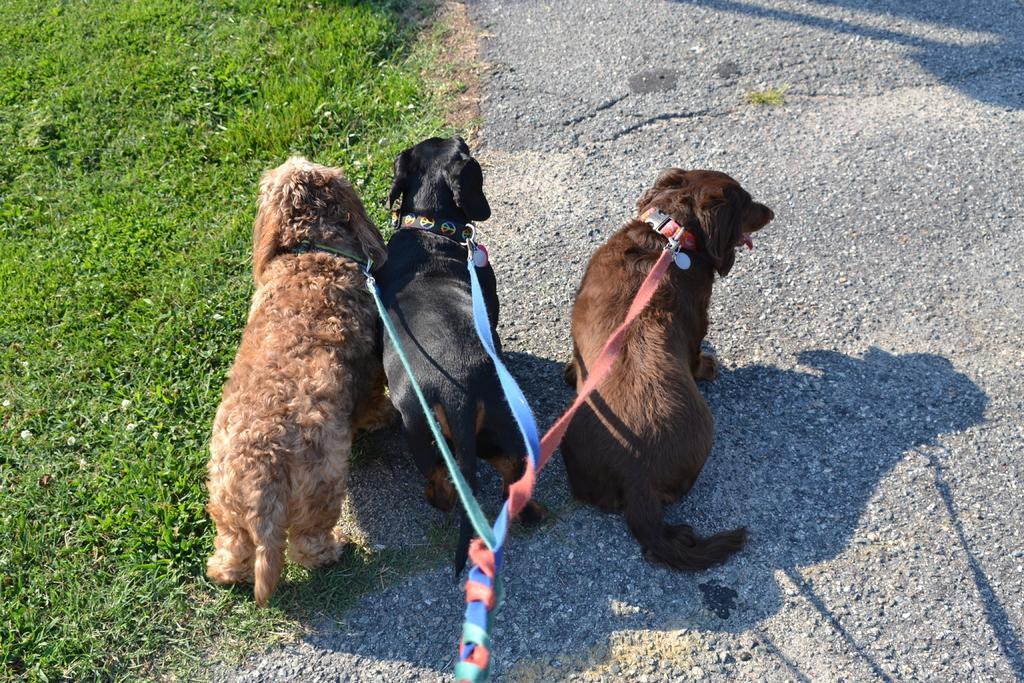Can you describe this image briefly? In this picture we can see few dogs and the dogs tied with belts, and also we can see grass. 